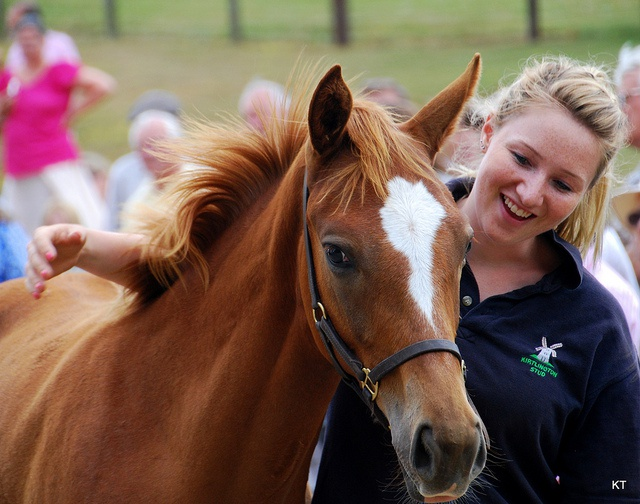Describe the objects in this image and their specific colors. I can see horse in darkgreen, maroon, black, brown, and gray tones, people in darkgreen, black, brown, darkgray, and pink tones, people in darkgreen, magenta, lavender, purple, and lightpink tones, people in darkgreen, lightgray, tan, and darkgray tones, and people in darkgreen, lavender, darkgray, gray, and tan tones in this image. 